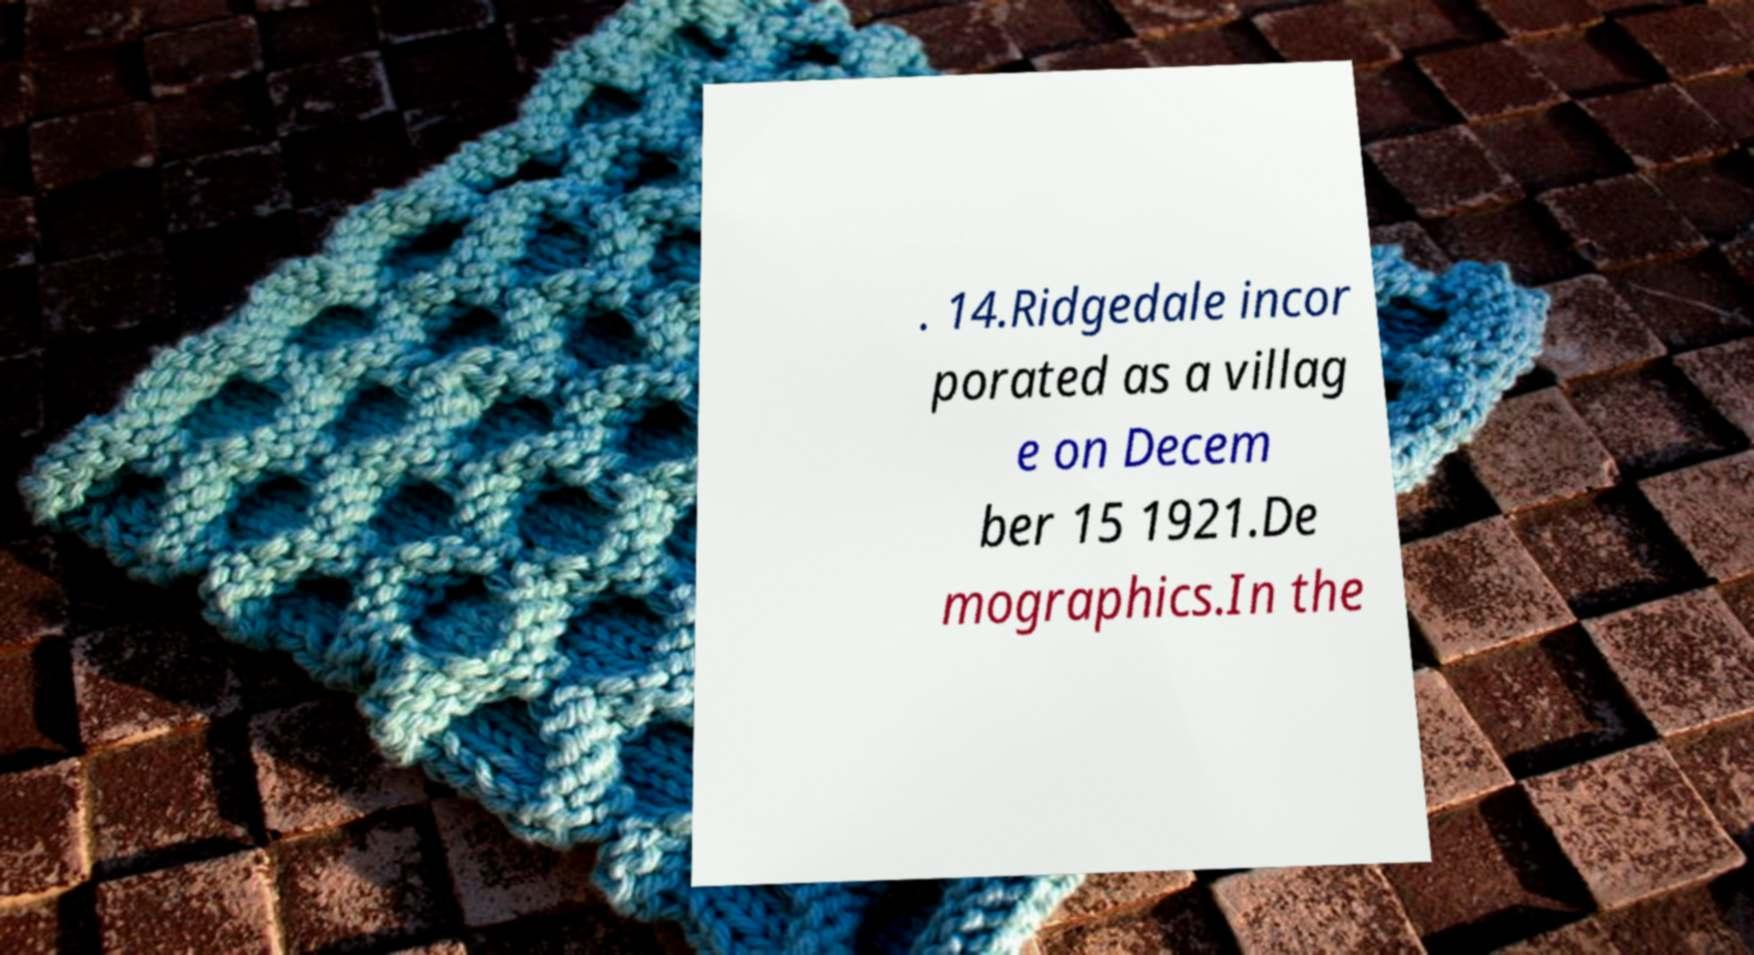Could you assist in decoding the text presented in this image and type it out clearly? . 14.Ridgedale incor porated as a villag e on Decem ber 15 1921.De mographics.In the 